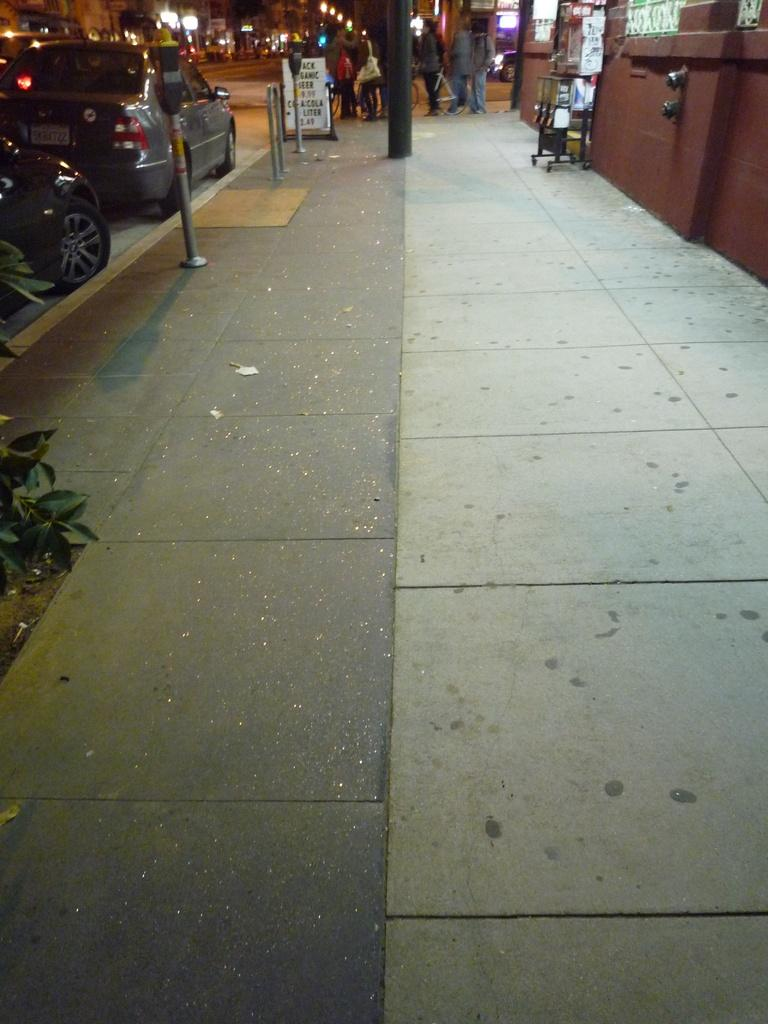What type of surface is visible on the left side of the image? There is a sidewalk in the image. What objects can be seen on the sidewalk? There are poles on the sidewalk. What else is visible near the sidewalk? There are vehicles near the sidewalk. What is located on the right side of the image? There is a wall on the right side of the image. What can be seen in the background of the image? There are lights visible in the background, and there are people present in the background. What type of chin does the lawyer have in the image? There is no lawyer present in the image, and therefore no chin to describe. 